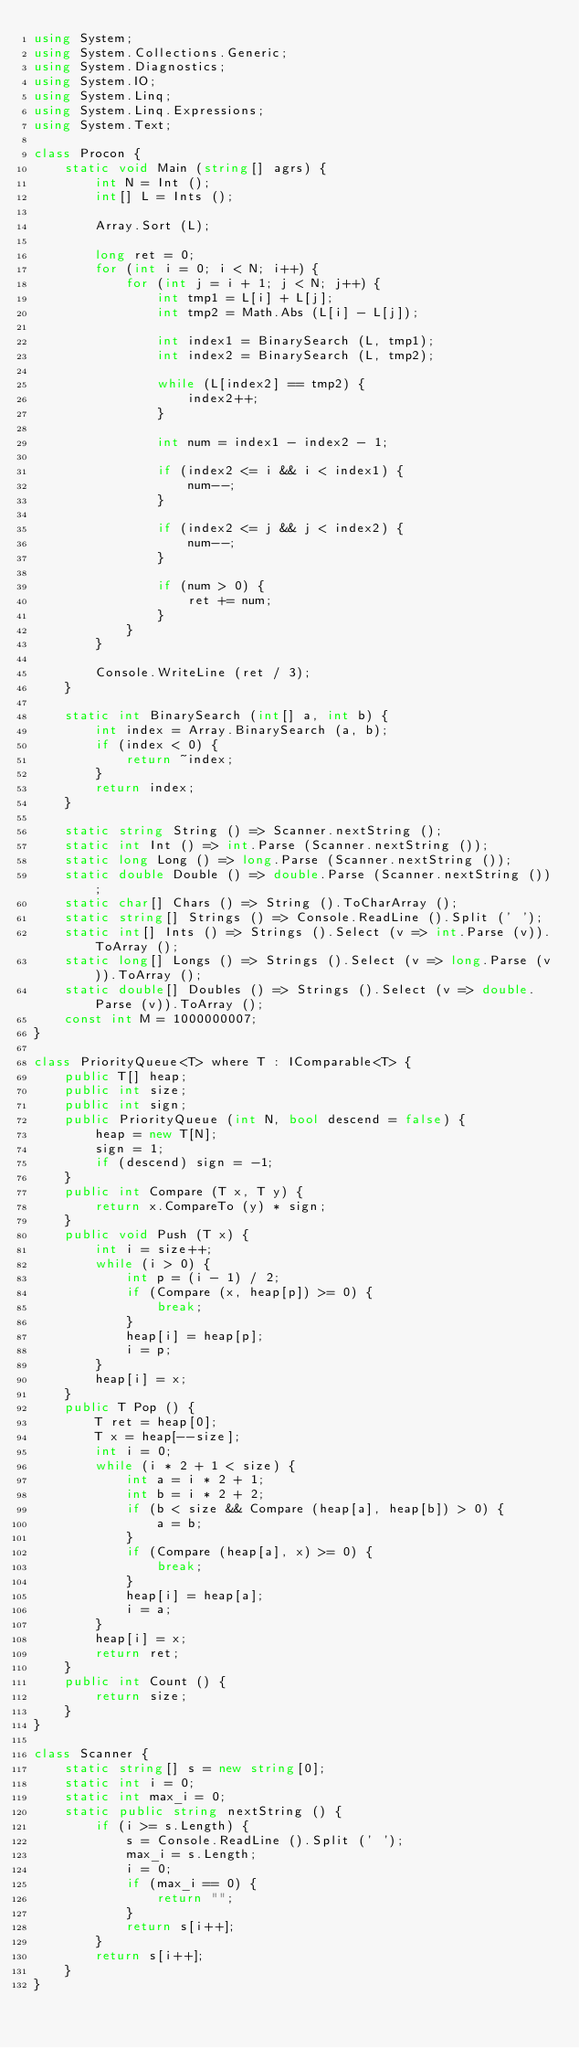<code> <loc_0><loc_0><loc_500><loc_500><_C#_>using System;
using System.Collections.Generic;
using System.Diagnostics;
using System.IO;
using System.Linq;
using System.Linq.Expressions;
using System.Text;

class Procon {
    static void Main (string[] agrs) {
        int N = Int ();
        int[] L = Ints ();

        Array.Sort (L);

        long ret = 0;
        for (int i = 0; i < N; i++) {
            for (int j = i + 1; j < N; j++) {
                int tmp1 = L[i] + L[j];
                int tmp2 = Math.Abs (L[i] - L[j]);

                int index1 = BinarySearch (L, tmp1);
                int index2 = BinarySearch (L, tmp2);

                while (L[index2] == tmp2) {
                    index2++;
                }

                int num = index1 - index2 - 1;

                if (index2 <= i && i < index1) {
                    num--;
                }

                if (index2 <= j && j < index2) {
                    num--;
                }

                if (num > 0) {
                    ret += num;
                }
            }
        }

        Console.WriteLine (ret / 3);
    }

    static int BinarySearch (int[] a, int b) {
        int index = Array.BinarySearch (a, b);
        if (index < 0) {
            return ~index;
        }
        return index;
    }

    static string String () => Scanner.nextString ();
    static int Int () => int.Parse (Scanner.nextString ());
    static long Long () => long.Parse (Scanner.nextString ());
    static double Double () => double.Parse (Scanner.nextString ());
    static char[] Chars () => String ().ToCharArray ();
    static string[] Strings () => Console.ReadLine ().Split (' ');
    static int[] Ints () => Strings ().Select (v => int.Parse (v)).ToArray ();
    static long[] Longs () => Strings ().Select (v => long.Parse (v)).ToArray ();
    static double[] Doubles () => Strings ().Select (v => double.Parse (v)).ToArray ();
    const int M = 1000000007;
}

class PriorityQueue<T> where T : IComparable<T> {
    public T[] heap;
    public int size;
    public int sign;
    public PriorityQueue (int N, bool descend = false) {
        heap = new T[N];
        sign = 1;
        if (descend) sign = -1;
    }
    public int Compare (T x, T y) {
        return x.CompareTo (y) * sign;
    }
    public void Push (T x) {
        int i = size++;
        while (i > 0) {
            int p = (i - 1) / 2;
            if (Compare (x, heap[p]) >= 0) {
                break;
            }
            heap[i] = heap[p];
            i = p;
        }
        heap[i] = x;
    }
    public T Pop () {
        T ret = heap[0];
        T x = heap[--size];
        int i = 0;
        while (i * 2 + 1 < size) {
            int a = i * 2 + 1;
            int b = i * 2 + 2;
            if (b < size && Compare (heap[a], heap[b]) > 0) {
                a = b;
            }
            if (Compare (heap[a], x) >= 0) {
                break;
            }
            heap[i] = heap[a];
            i = a;
        }
        heap[i] = x;
        return ret;
    }
    public int Count () {
        return size;
    }
}

class Scanner {
    static string[] s = new string[0];
    static int i = 0;
    static int max_i = 0;
    static public string nextString () {
        if (i >= s.Length) {
            s = Console.ReadLine ().Split (' ');
            max_i = s.Length;
            i = 0;
            if (max_i == 0) {
                return "";
            }
            return s[i++];
        }
        return s[i++];
    }
}</code> 